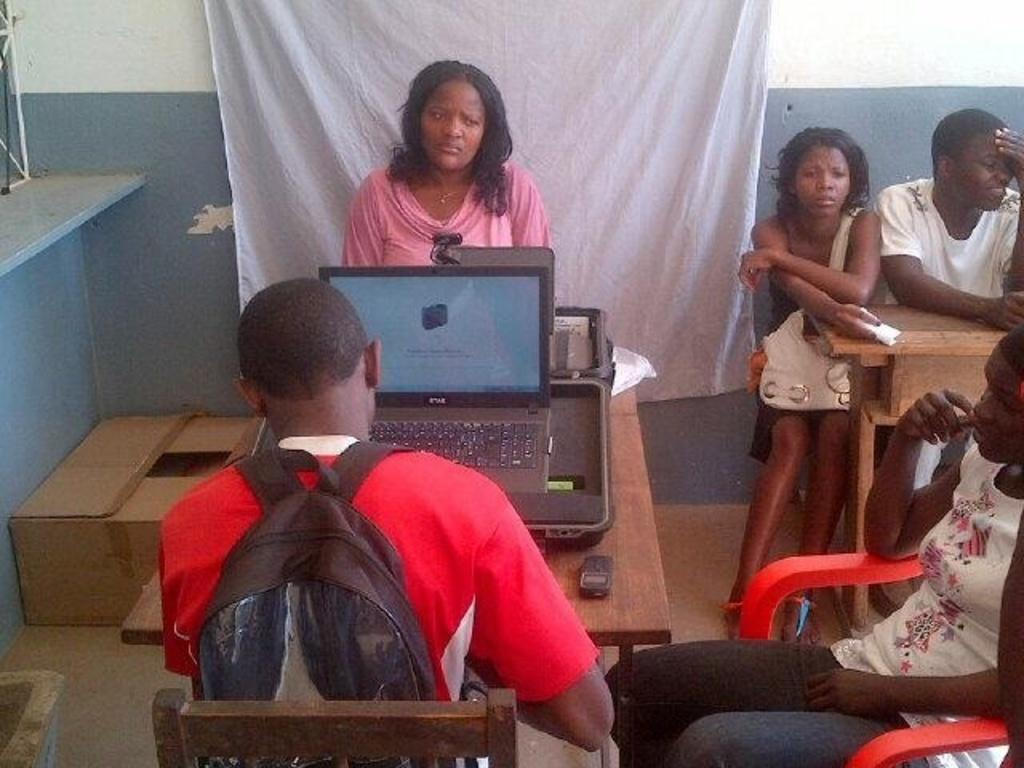How many people are in the image? There is a group of people in the image. What are some of the people in the image doing? Some people are sitting on chairs in front of a table, while others are standing. What can be seen on the table in the image? There is a laptop on the table, along with other objects. Where is the toothbrush located in the image? There is no toothbrush present in the image. How many cherries are on the table in the image? There are no cherries present in the image. 